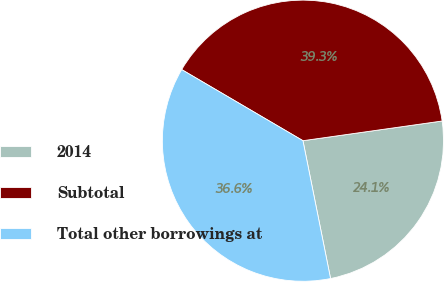Convert chart. <chart><loc_0><loc_0><loc_500><loc_500><pie_chart><fcel>2014<fcel>Subtotal<fcel>Total other borrowings at<nl><fcel>24.09%<fcel>39.32%<fcel>36.59%<nl></chart> 